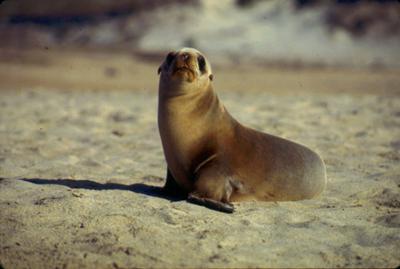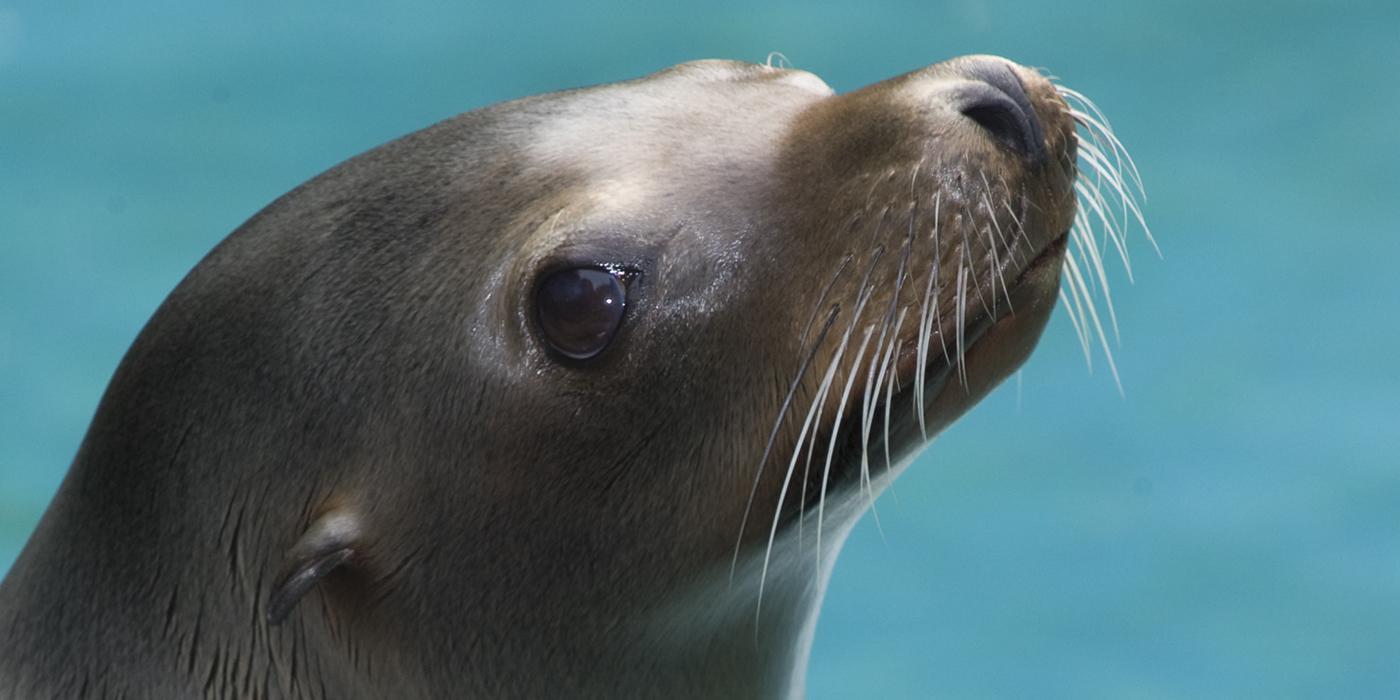The first image is the image on the left, the second image is the image on the right. Given the left and right images, does the statement "One or more seals are sitting on a rock in both images." hold true? Answer yes or no. No. 